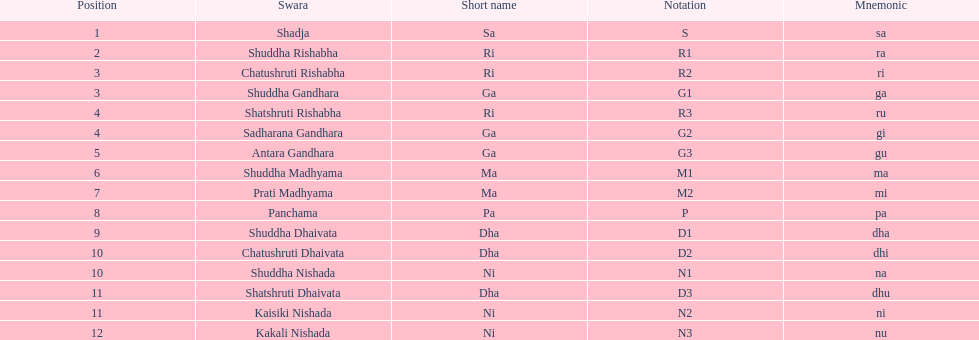What is the name of the swara that comes after panchama? Shuddha Dhaivata. 